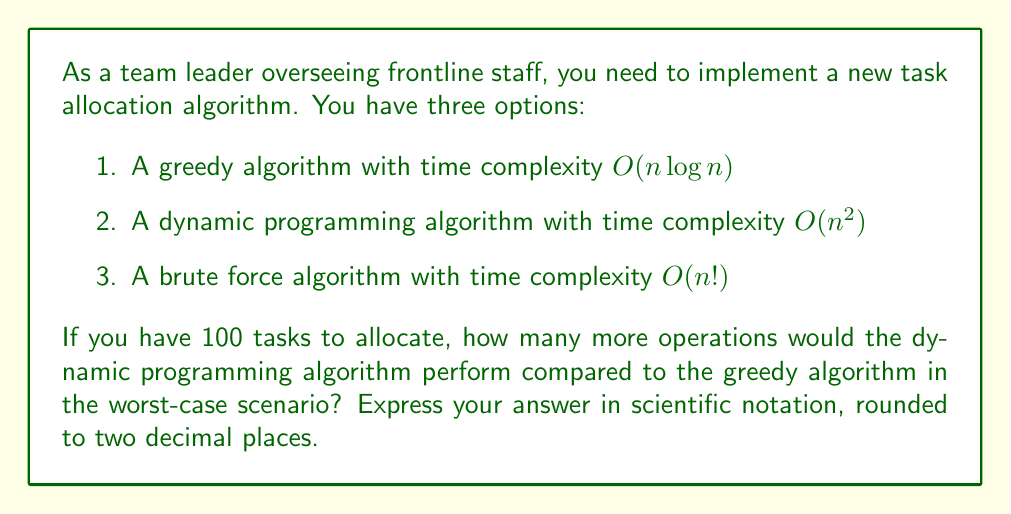Help me with this question. To solve this problem, we need to follow these steps:

1. Calculate the number of operations for the greedy algorithm:
   $$O(n \log n) = 100 \log 100 \approx 100 \times 4.6052 = 460.52$$

2. Calculate the number of operations for the dynamic programming algorithm:
   $$O(n^2) = 100^2 = 10,000$$

3. Find the difference between the two:
   $$10,000 - 460.52 = 9,539.48$$

4. Express the result in scientific notation, rounded to two decimal places:
   $$9,539.48 \approx 9.54 \times 10^3$$

Note that these calculations are based on the asymptotic complexity and ignore constant factors. In practice, the actual number of operations may vary, but this gives us a good estimate of the relative performance difference between the algorithms.

The brute force algorithm with $O(n!)$ complexity is not considered in this comparison as it would be impractical for 100 tasks, resulting in an enormous number of operations: $100! \approx 9.33 \times 10^{157}$.
Answer: $9.54 \times 10^3$ 